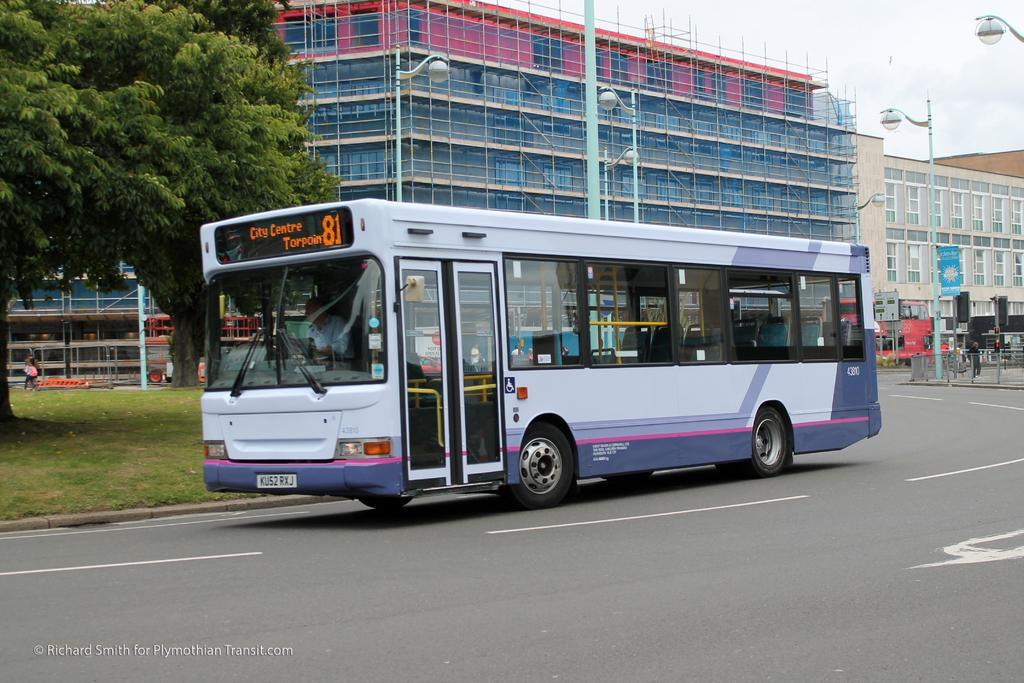<image>
Describe the image concisely. Bus route 81 is heading to the City Centre. 